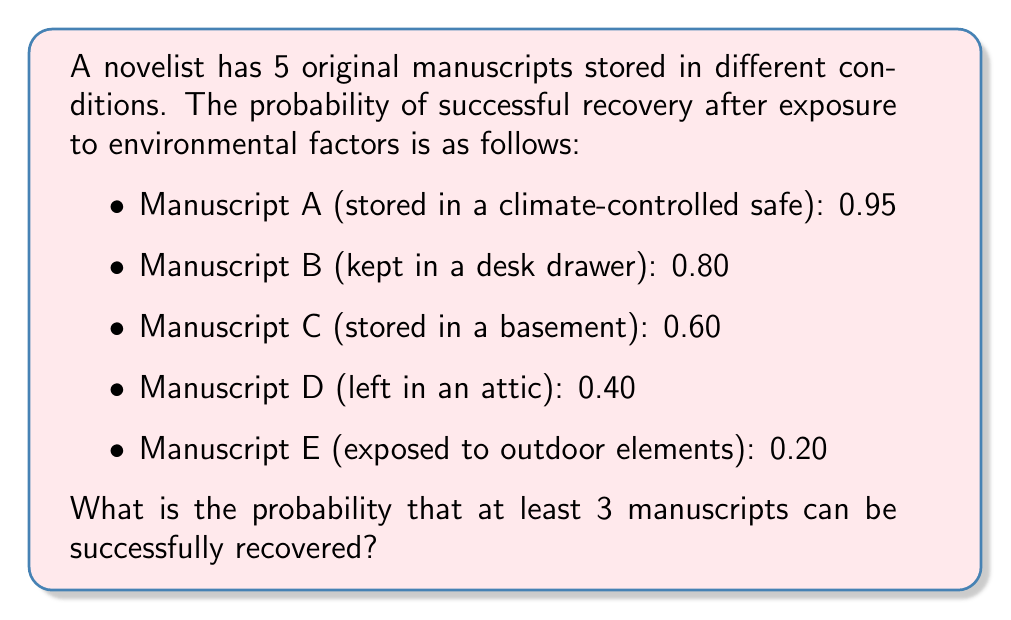Help me with this question. To solve this problem, we'll use the complementary approach:
P(at least 3 recovered) = 1 - P(0, 1, or 2 recovered)

Let's calculate the probability of each case:

1. P(all 5 fail) = $(1-0.95)(1-0.80)(1-0.60)(1-0.40)(1-0.20) = 0.00024$

2. P(exactly 1 succeeds) = 
   $0.95(1-0.80)(1-0.60)(1-0.40)(1-0.20) +$
   $(1-0.95)0.80(1-0.60)(1-0.40)(1-0.20) +$
   $(1-0.95)(1-0.80)0.60(1-0.40)(1-0.20) +$
   $(1-0.95)(1-0.80)(1-0.60)0.40(1-0.20) +$
   $(1-0.95)(1-0.80)(1-0.60)(1-0.40)0.20$
   $= 0.00456 + 0.00384 + 0.00288 + 0.00192 + 0.00096 = 0.01416$

3. P(exactly 2 succeed) = 
   $0.95 \cdot 0.80(1-0.60)(1-0.40)(1-0.20) +$
   $0.95 \cdot (1-0.80)0.60(1-0.40)(1-0.20) +$
   $0.95 \cdot (1-0.80)(1-0.60)0.40(1-0.20) +$
   $0.95 \cdot (1-0.80)(1-0.60)(1-0.40)0.20 +$
   $(1-0.95)0.80 \cdot 0.60(1-0.40)(1-0.20) +$
   $(1-0.95)0.80 \cdot (1-0.60)0.40(1-0.20) +$
   $(1-0.95)0.80 \cdot (1-0.60)(1-0.40)0.20 +$
   $(1-0.95)(1-0.80)0.60 \cdot 0.40(1-0.20) +$
   $(1-0.95)(1-0.80)0.60 \cdot (1-0.40)0.20 +$
   $(1-0.95)(1-0.80)(1-0.60)0.40 \cdot 0.20$
   $= 0.07296 + 0.05472 + 0.03648 + 0.01824 + 0.00576 + 0.00384 + 0.00192 + 0.00288 + 0.00144 + 0.00096 = 0.1992$

P(0, 1, or 2 recovered) = $0.00024 + 0.01416 + 0.1992 = 0.2136$

Therefore, P(at least 3 recovered) = $1 - 0.2136 = 0.7864$
Answer: 0.7864 